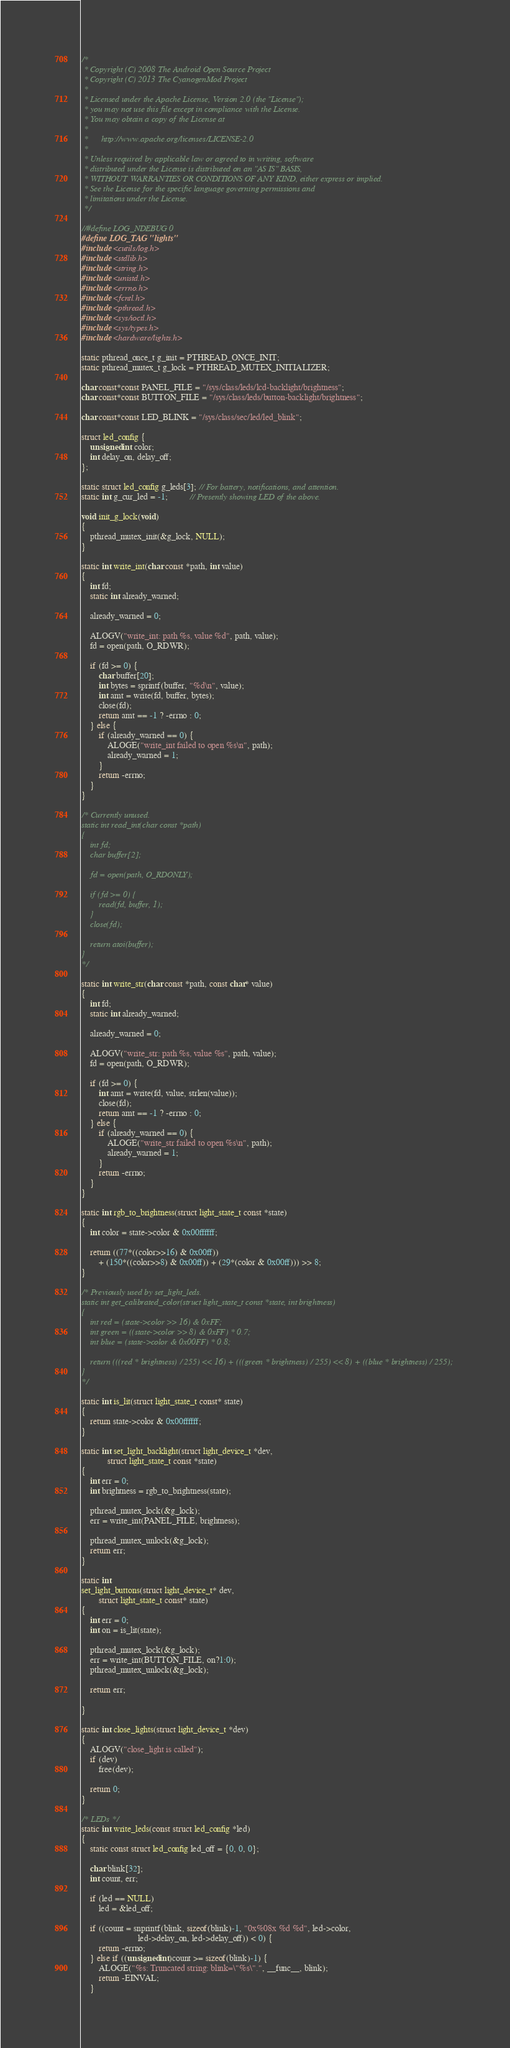<code> <loc_0><loc_0><loc_500><loc_500><_C_>/*
 * Copyright (C) 2008 The Android Open Source Project
 * Copyright (C) 2013 The CyanogenMod Project
 *
 * Licensed under the Apache License, Version 2.0 (the "License");
 * you may not use this file except in compliance with the License.
 * You may obtain a copy of the License at
 *
 *      http://www.apache.org/licenses/LICENSE-2.0
 *
 * Unless required by applicable law or agreed to in writing, software
 * distributed under the License is distributed on an "AS IS" BASIS,
 * WITHOUT WARRANTIES OR CONDITIONS OF ANY KIND, either express or implied.
 * See the License for the specific language governing permissions and
 * limitations under the License.
 */

//#define LOG_NDEBUG 0
#define LOG_TAG "lights"
#include <cutils/log.h>
#include <stdlib.h>
#include <string.h>
#include <unistd.h>
#include <errno.h>
#include <fcntl.h>
#include <pthread.h>
#include <sys/ioctl.h>
#include <sys/types.h>
#include <hardware/lights.h>

static pthread_once_t g_init = PTHREAD_ONCE_INIT;
static pthread_mutex_t g_lock = PTHREAD_MUTEX_INITIALIZER;

char const*const PANEL_FILE = "/sys/class/leds/lcd-backlight/brightness";
char const*const BUTTON_FILE = "/sys/class/leds/button-backlight/brightness";

char const*const LED_BLINK = "/sys/class/sec/led/led_blink";

struct led_config {
    unsigned int color;
    int delay_on, delay_off;
};

static struct led_config g_leds[3]; // For battery, notifications, and attention.
static int g_cur_led = -1;          // Presently showing LED of the above.

void init_g_lock(void)
{
    pthread_mutex_init(&g_lock, NULL);
}

static int write_int(char const *path, int value)
{
    int fd;
    static int already_warned;

    already_warned = 0;

    ALOGV("write_int: path %s, value %d", path, value);
    fd = open(path, O_RDWR);

    if (fd >= 0) {
        char buffer[20];
        int bytes = sprintf(buffer, "%d\n", value);
        int amt = write(fd, buffer, bytes);
        close(fd);
        return amt == -1 ? -errno : 0;
    } else {
        if (already_warned == 0) {
            ALOGE("write_int failed to open %s\n", path);
            already_warned = 1;
        }
        return -errno;
    }
}

/* Currently unused.
static int read_int(char const *path)
{
    int fd;
    char buffer[2];

    fd = open(path, O_RDONLY);

    if (fd >= 0) {
        read(fd, buffer, 1);
    }
    close(fd);

    return atoi(buffer);
}
*/

static int write_str(char const *path, const char* value)
{
    int fd;
    static int already_warned;

    already_warned = 0;

    ALOGV("write_str: path %s, value %s", path, value);
    fd = open(path, O_RDWR);

    if (fd >= 0) {
        int amt = write(fd, value, strlen(value));
        close(fd);
        return amt == -1 ? -errno : 0;
    } else {
        if (already_warned == 0) {
            ALOGE("write_str failed to open %s\n", path);
            already_warned = 1;
        }
        return -errno;
    }
}

static int rgb_to_brightness(struct light_state_t const *state)
{
    int color = state->color & 0x00ffffff;

    return ((77*((color>>16) & 0x00ff))
        + (150*((color>>8) & 0x00ff)) + (29*(color & 0x00ff))) >> 8;
}

/* Previously used by set_light_leds.
static int get_calibrated_color(struct light_state_t const *state, int brightness)
{
    int red = (state->color >> 16) & 0xFF;
    int green = ((state->color >> 8) & 0xFF) * 0.7;
    int blue = (state->color & 0x00FF) * 0.8;

    return (((red * brightness) / 255) << 16) + (((green * brightness) / 255) << 8) + ((blue * brightness) / 255);
}
*/

static int is_lit(struct light_state_t const* state)
{
    return state->color & 0x00ffffff;
}

static int set_light_backlight(struct light_device_t *dev,
            struct light_state_t const *state)
{
    int err = 0;
    int brightness = rgb_to_brightness(state);

    pthread_mutex_lock(&g_lock);
    err = write_int(PANEL_FILE, brightness);

    pthread_mutex_unlock(&g_lock);
    return err;
}

static int
set_light_buttons(struct light_device_t* dev,
        struct light_state_t const* state)
{
    int err = 0;
    int on = is_lit(state);

    pthread_mutex_lock(&g_lock);
    err = write_int(BUTTON_FILE, on?1:0);
    pthread_mutex_unlock(&g_lock);

    return err;

}

static int close_lights(struct light_device_t *dev)
{
    ALOGV("close_light is called");
    if (dev)
        free(dev);

    return 0;
}

/* LEDs */
static int write_leds(const struct led_config *led)
{
    static const struct led_config led_off = {0, 0, 0};

    char blink[32];
    int count, err;

    if (led == NULL)
        led = &led_off;

    if ((count = snprintf(blink, sizeof(blink)-1, "0x%08x %d %d", led->color,
                          led->delay_on, led->delay_off)) < 0) {
        return -errno;
    } else if ((unsigned int)count >= sizeof(blink)-1) {
        ALOGE("%s: Truncated string: blink=\"%s\".", __func__, blink);
        return -EINVAL;
    }
</code> 